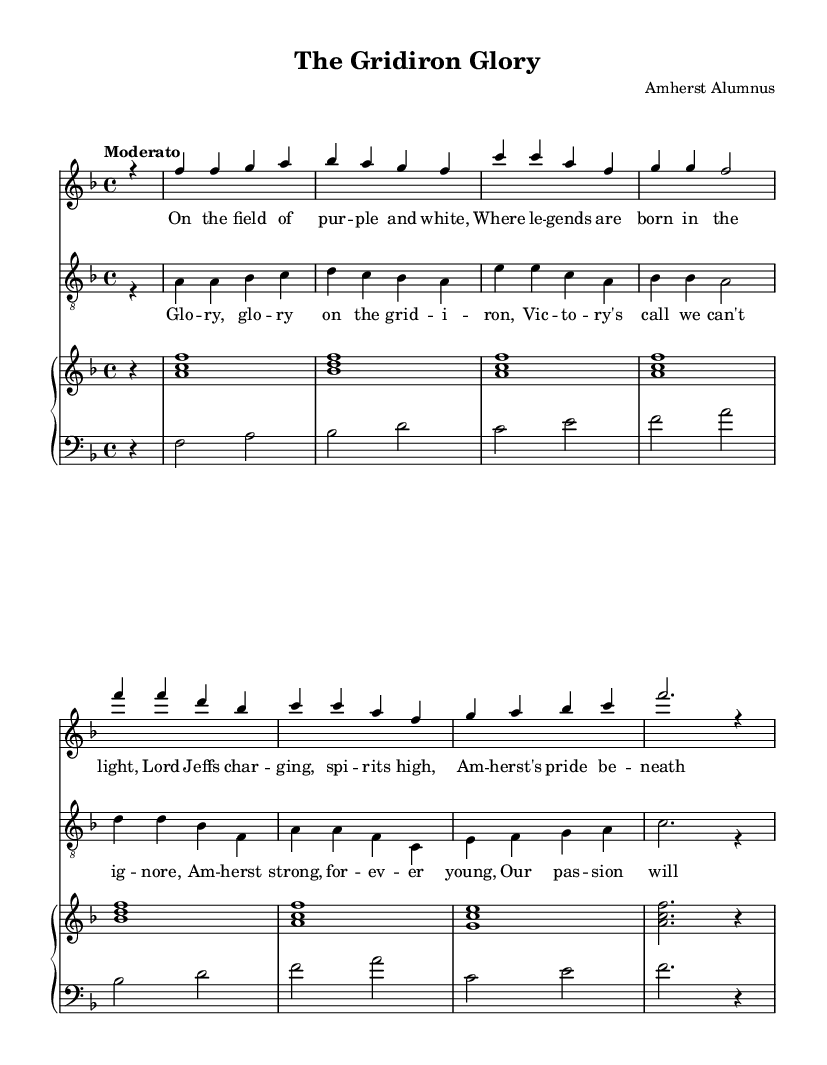What is the key signature of this music? The key signature is indicated by the 'key' command in the global section. In this case, it is F major, which has one flat (B♭).
Answer: F major What is the time signature of this music? The time signature is shown in the global section as '4/4', which means there are four beats per measure and the quarter note gets one beat.
Answer: 4/4 What is the tempo marking of the piece? The tempo is indicated by the 'tempo' command in the global section, stating "Moderato," which denotes a moderate speed for the piece.
Answer: Moderato How many staves are provided in the score? The score section contains multiple staff elements, specifically one for soprano, one for tenor, and a piano staff that includes both upper and lower staves, making a total of four staves.
Answer: 4 What is the title of the opera? The title is specified in the header section of the code, which indicates the name of the piece. The title presented is "The Gridiron Glory."
Answer: The Gridiron Glory Who is the composer of this piece? The composer is listed in the header section as "Amherst Alumnus," indicating the author of the music.
Answer: Amherst Alumnus What themes are expressed in the lyrics? Analyzing the lyrics provided in the 'verse' and 'chorus' sections, the themes reflect athletic pride and camaraderie, particularly focused on football and college spirit.
Answer: Athletic pride and camaraderie 